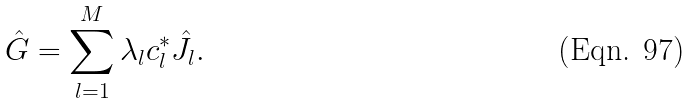Convert formula to latex. <formula><loc_0><loc_0><loc_500><loc_500>\hat { G } = \sum _ { l = 1 } ^ { M } \lambda _ { l } c _ { l } ^ { \ast } \hat { J } _ { l } .</formula> 